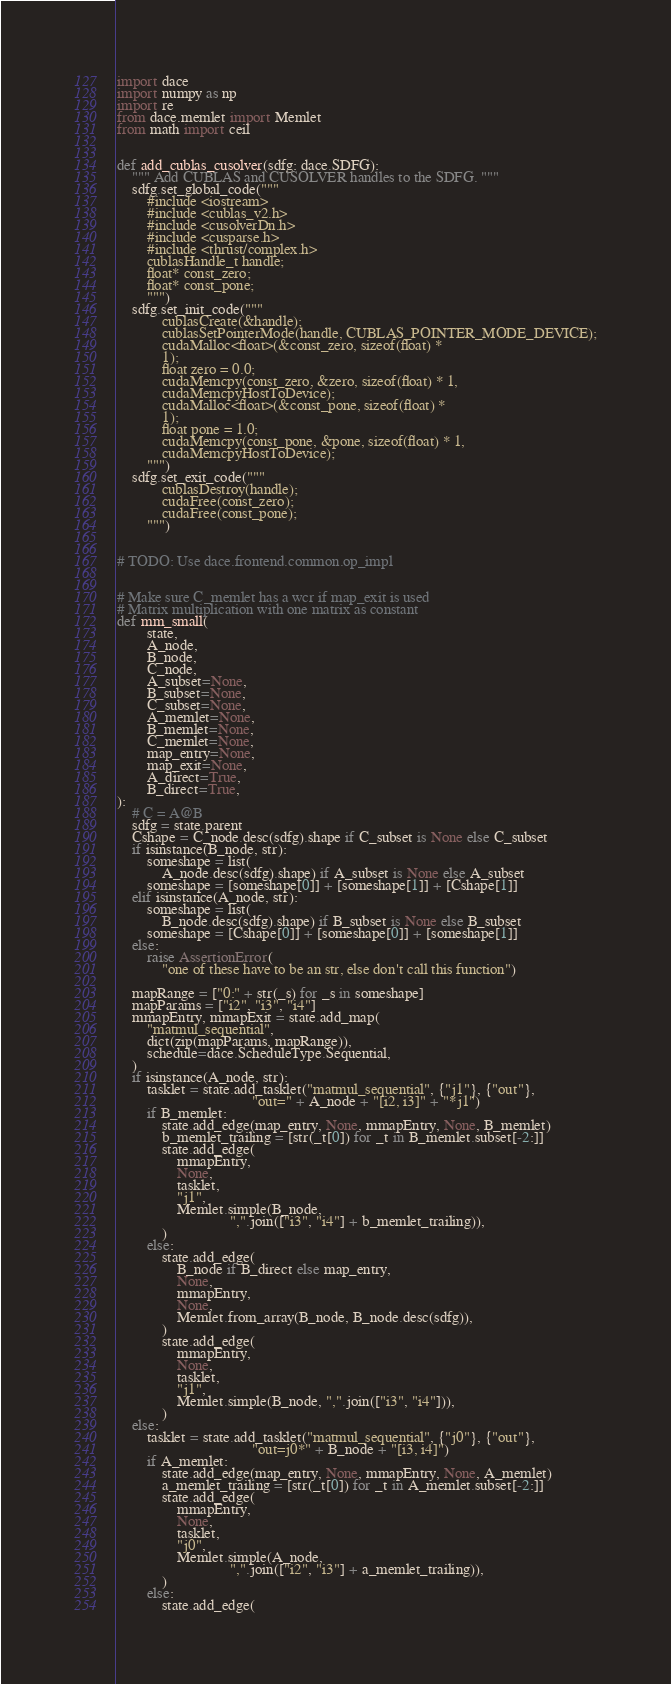<code> <loc_0><loc_0><loc_500><loc_500><_Python_>import dace
import numpy as np
import re
from dace.memlet import Memlet
from math import ceil


def add_cublas_cusolver(sdfg: dace.SDFG):
    """ Add CUBLAS and CUSOLVER handles to the SDFG. """
    sdfg.set_global_code("""
        #include <iostream>
        #include <cublas_v2.h>
        #include <cusolverDn.h>
        #include <cusparse.h>
        #include <thrust/complex.h>
        cublasHandle_t handle;
        float* const_zero;
        float* const_pone;
        """)
    sdfg.set_init_code("""
            cublasCreate(&handle);
            cublasSetPointerMode(handle, CUBLAS_POINTER_MODE_DEVICE);
            cudaMalloc<float>(&const_zero, sizeof(float) *
            1);
            float zero = 0.0;
            cudaMemcpy(const_zero, &zero, sizeof(float) * 1,
            cudaMemcpyHostToDevice);
            cudaMalloc<float>(&const_pone, sizeof(float) *
            1);
            float pone = 1.0;
            cudaMemcpy(const_pone, &pone, sizeof(float) * 1,
            cudaMemcpyHostToDevice);
        """)
    sdfg.set_exit_code("""
            cublasDestroy(handle);
            cudaFree(const_zero);
            cudaFree(const_pone);
        """)


# TODO: Use dace.frontend.common.op_impl


# Make sure C_memlet has a wcr if map_exit is used
# Matrix multiplication with one matrix as constant
def mm_small(
        state,
        A_node,
        B_node,
        C_node,
        A_subset=None,
        B_subset=None,
        C_subset=None,
        A_memlet=None,
        B_memlet=None,
        C_memlet=None,
        map_entry=None,
        map_exit=None,
        A_direct=True,
        B_direct=True,
):
    # C = A@B
    sdfg = state.parent
    Cshape = C_node.desc(sdfg).shape if C_subset is None else C_subset
    if isinstance(B_node, str):
        someshape = list(
            A_node.desc(sdfg).shape) if A_subset is None else A_subset
        someshape = [someshape[0]] + [someshape[1]] + [Cshape[1]]
    elif isinstance(A_node, str):
        someshape = list(
            B_node.desc(sdfg).shape) if B_subset is None else B_subset
        someshape = [Cshape[0]] + [someshape[0]] + [someshape[1]]
    else:
        raise AssertionError(
            "one of these have to be an str, else don't call this function")

    mapRange = ["0:" + str(_s) for _s in someshape]
    mapParams = ["i2", "i3", "i4"]
    mmapEntry, mmapExit = state.add_map(
        "matmul_sequential",
        dict(zip(mapParams, mapRange)),
        schedule=dace.ScheduleType.Sequential,
    )
    if isinstance(A_node, str):
        tasklet = state.add_tasklet("matmul_sequential", {"j1"}, {"out"},
                                    "out=" + A_node + "[i2, i3]" + "*j1")
        if B_memlet:
            state.add_edge(map_entry, None, mmapEntry, None, B_memlet)
            b_memlet_trailing = [str(_t[0]) for _t in B_memlet.subset[-2:]]
            state.add_edge(
                mmapEntry,
                None,
                tasklet,
                "j1",
                Memlet.simple(B_node,
                              ",".join(["i3", "i4"] + b_memlet_trailing)),
            )
        else:
            state.add_edge(
                B_node if B_direct else map_entry,
                None,
                mmapEntry,
                None,
                Memlet.from_array(B_node, B_node.desc(sdfg)),
            )
            state.add_edge(
                mmapEntry,
                None,
                tasklet,
                "j1",
                Memlet.simple(B_node, ",".join(["i3", "i4"])),
            )
    else:
        tasklet = state.add_tasklet("matmul_sequential", {"j0"}, {"out"},
                                    "out=j0*" + B_node + "[i3, i4]")
        if A_memlet:
            state.add_edge(map_entry, None, mmapEntry, None, A_memlet)
            a_memlet_trailing = [str(_t[0]) for _t in A_memlet.subset[-2:]]
            state.add_edge(
                mmapEntry,
                None,
                tasklet,
                "j0",
                Memlet.simple(A_node,
                              ",".join(["i2", "i3"] + a_memlet_trailing)),
            )
        else:
            state.add_edge(</code> 